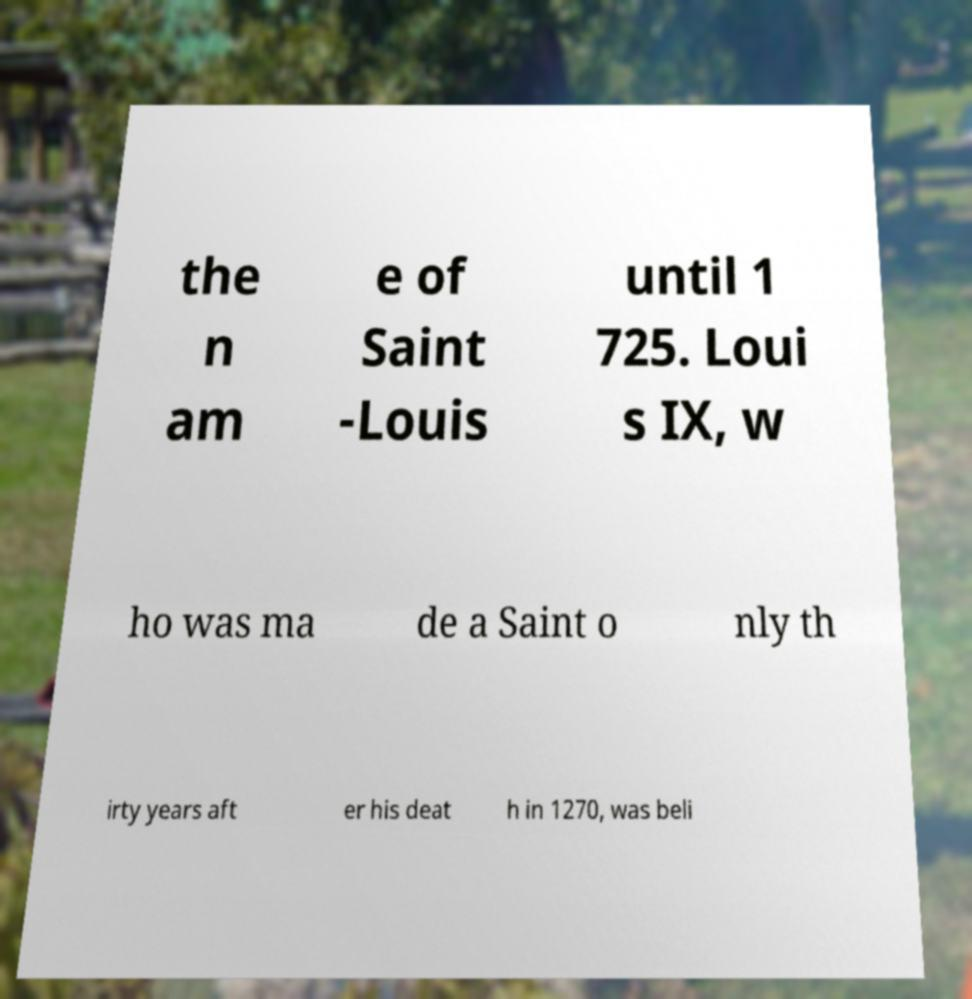Could you extract and type out the text from this image? the n am e of Saint -Louis until 1 725. Loui s IX, w ho was ma de a Saint o nly th irty years aft er his deat h in 1270, was beli 